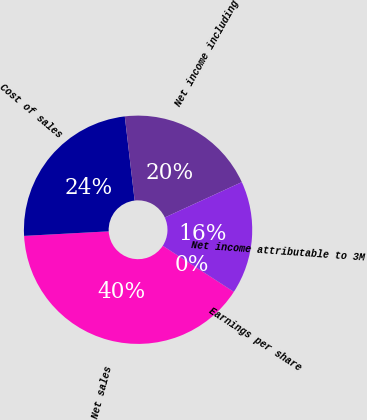<chart> <loc_0><loc_0><loc_500><loc_500><pie_chart><fcel>Net sales<fcel>Cost of sales<fcel>Net income including<fcel>Net income attributable to 3M<fcel>Earnings per share<nl><fcel>39.99%<fcel>24.0%<fcel>20.0%<fcel>16.0%<fcel>0.01%<nl></chart> 